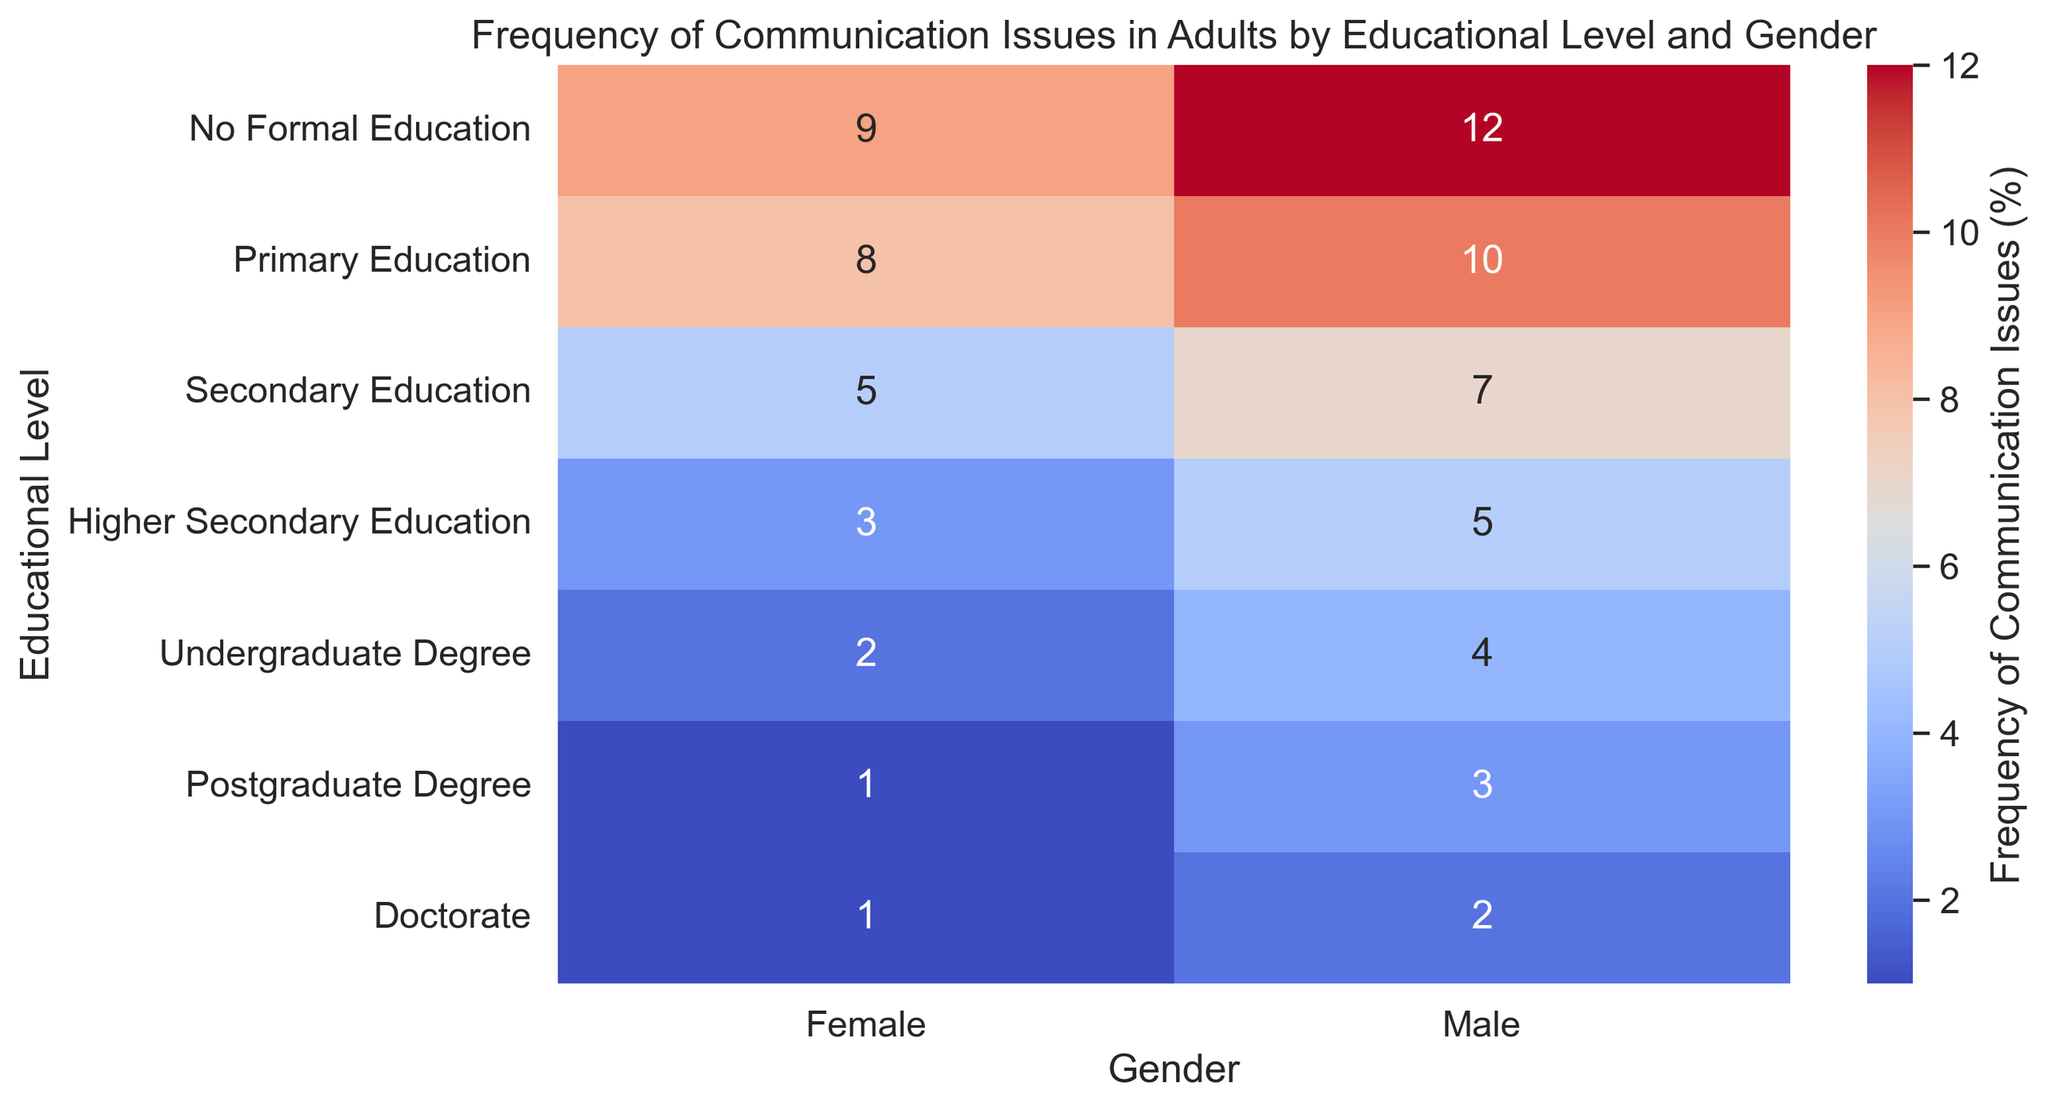What's the percentage of communication issues for males with no formal education? Look for the cell corresponding to "No Formal Education" in the "Educational Level" axis and "Male" in the "Gender" axis, which is labeled with the percentage.
Answer: 12% For which gender does the frequency of communication issues decrease more significantly as the educational level increases? Compare the decreasing trend in percentages for both males and females across the educational levels. Males decrease from 12% to 2%, while females decrease from 9% to 1%, showing a more significant decrease in males.
Answer: Males What is the difference in the frequency of communication issues between males and females with an undergraduate degree? Find the respective frequencies for both genders with an undergraduate degree. Males have 4% and females have 2%. Subtract the female frequency from the male frequency (4% - 2%).
Answer: 2% On average, what percentage of communication issues do females face across all educational levels? Sum the percentages for all educational levels for females (9 + 8 + 5 + 3 + 2 + 1 + 1 = 29). Then, divide by the number of educational levels (7): 29/7 ≈ 4.14%.
Answer: 4.14% Which educational level shows the smallest difference in communication issues between males and females? Calculate the differences for each educational level: No Formal Education (3%), Primary Education (2%), Secondary Education (2%), Higher Secondary Education (2%), Undergraduate Degree (2%), Postgraduate Degree (2%), and Doctorate (1%). The smallest difference is at the Doctorate level.
Answer: Doctorate How does the color gradient change as the frequency of communication issues decreases from no formal education to doctorate for males? Observe the color gradient in the heatmap for males from the top to the bottom row. The color changes from darker red at "No Formal Education" to lighter blue at "Doctorate," indicating a decrease in percentage.
Answer: From darker red to lighter blue Which educational level and gender combination shows the highest frequency of communication issues? Look for the cell with the highest numerical value in the heatmap. It is for males with no formal education, showing 12%.
Answer: No Formal Education, Male By how much does the frequency of communication issues decrease for males when moving from primary to higher secondary education? Find the percentages for primary education (10%) and higher secondary education (5%) and then subtract the latter from the former (10% - 5%).
Answer: 5% What is the visual difference between the cells representing males with postgraduate degrees and females with no formal education? Observe the colors of the respective cells. Males with postgraduate degrees have a lighter blue, while females with no formal education have a darker orange-red.
Answer: Lighter blue vs. darker orange-red What is the combined frequency of communication issues for both genders with secondary education? Find the percentages for males and females with secondary education (7% and 5% respectively). Add them together (7% + 5%).
Answer: 12% 